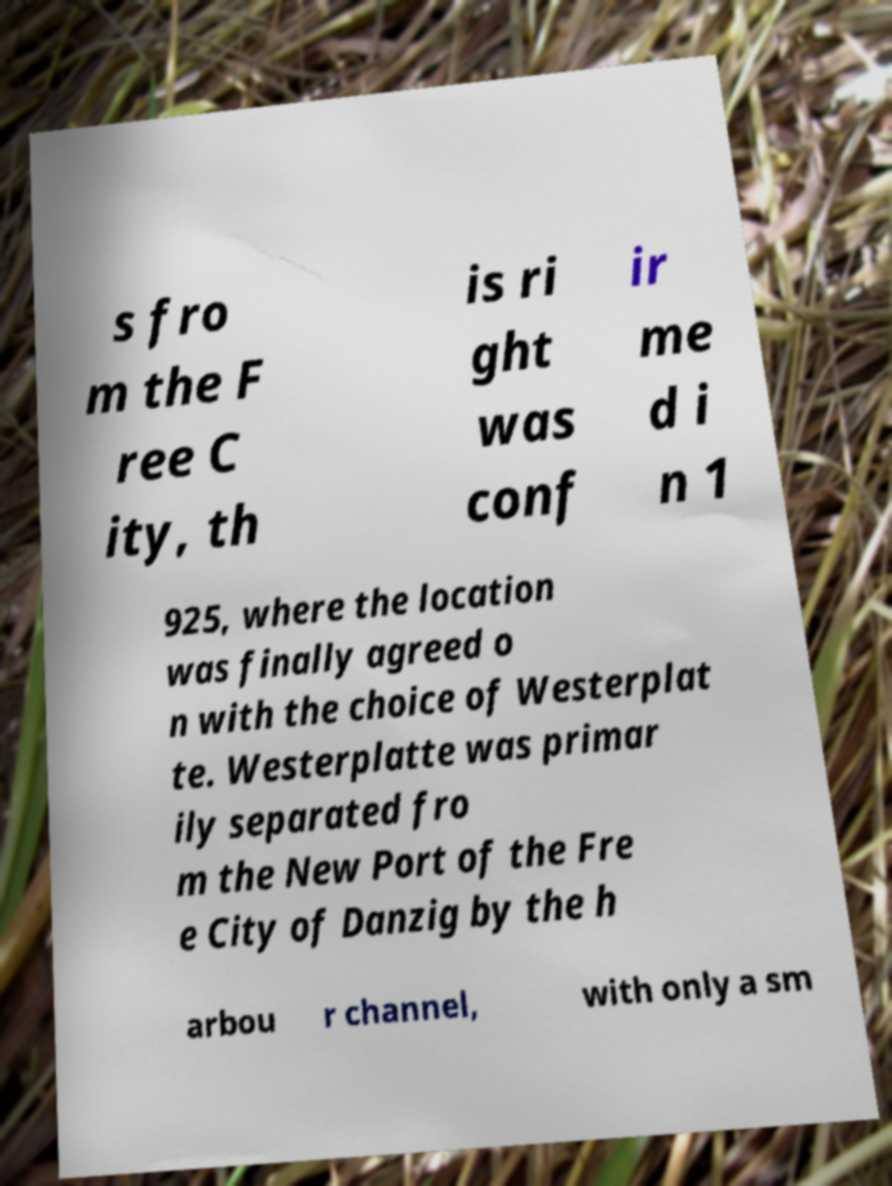There's text embedded in this image that I need extracted. Can you transcribe it verbatim? s fro m the F ree C ity, th is ri ght was conf ir me d i n 1 925, where the location was finally agreed o n with the choice of Westerplat te. Westerplatte was primar ily separated fro m the New Port of the Fre e City of Danzig by the h arbou r channel, with only a sm 